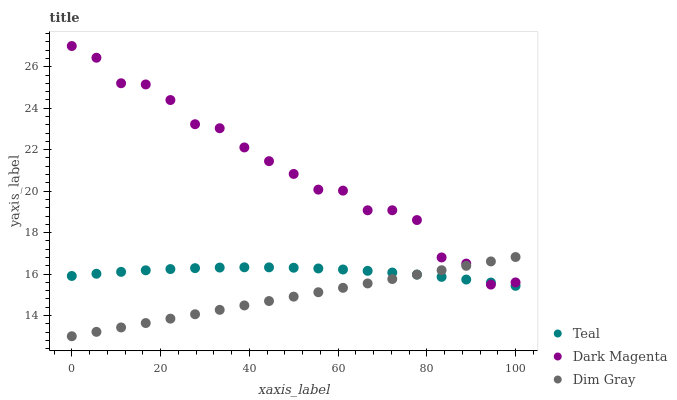Does Dim Gray have the minimum area under the curve?
Answer yes or no. Yes. Does Dark Magenta have the maximum area under the curve?
Answer yes or no. Yes. Does Teal have the minimum area under the curve?
Answer yes or no. No. Does Teal have the maximum area under the curve?
Answer yes or no. No. Is Dim Gray the smoothest?
Answer yes or no. Yes. Is Dark Magenta the roughest?
Answer yes or no. Yes. Is Teal the smoothest?
Answer yes or no. No. Is Teal the roughest?
Answer yes or no. No. Does Dim Gray have the lowest value?
Answer yes or no. Yes. Does Teal have the lowest value?
Answer yes or no. No. Does Dark Magenta have the highest value?
Answer yes or no. Yes. Does Teal have the highest value?
Answer yes or no. No. Does Dark Magenta intersect Dim Gray?
Answer yes or no. Yes. Is Dark Magenta less than Dim Gray?
Answer yes or no. No. Is Dark Magenta greater than Dim Gray?
Answer yes or no. No. 